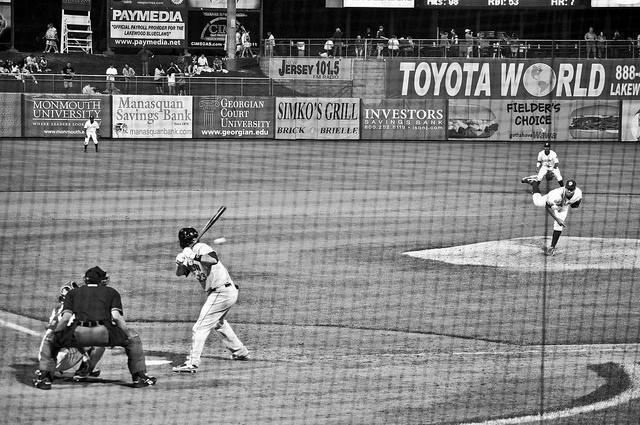What state is this field most likely in?
Indicate the correct response and explain using: 'Answer: answer
Rationale: rationale.'
Options: Kansas, maine, florida, new jersey. Answer: new jersey.
Rationale: There is a radio station billboard with a station called "jersey" on it which is likely in reference to the state. radio stations often only advertise at stadiums within their state. 